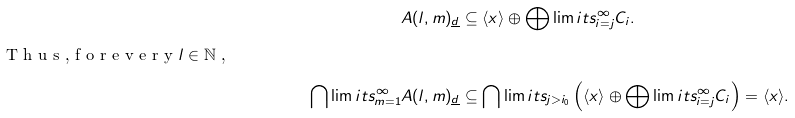Convert formula to latex. <formula><loc_0><loc_0><loc_500><loc_500>A ( l , m ) _ { \underline { d } } & \subseteq \langle x \rangle \oplus \bigoplus \lim i t s _ { i = j } ^ { \infty } C _ { i } . \\ \intertext { T h u s , f o r e v e r y $ l \in \mathbb { N } $ , } \bigcap \lim i t s _ { m = 1 } ^ { \infty } A ( l , m ) _ { \underline { d } } & \subseteq \bigcap \lim i t s _ { j > i _ { 0 } } \left ( \langle x \rangle \oplus \bigoplus \lim i t s _ { i = j } ^ { \infty } C _ { i } \right ) = \langle x \rangle .</formula> 